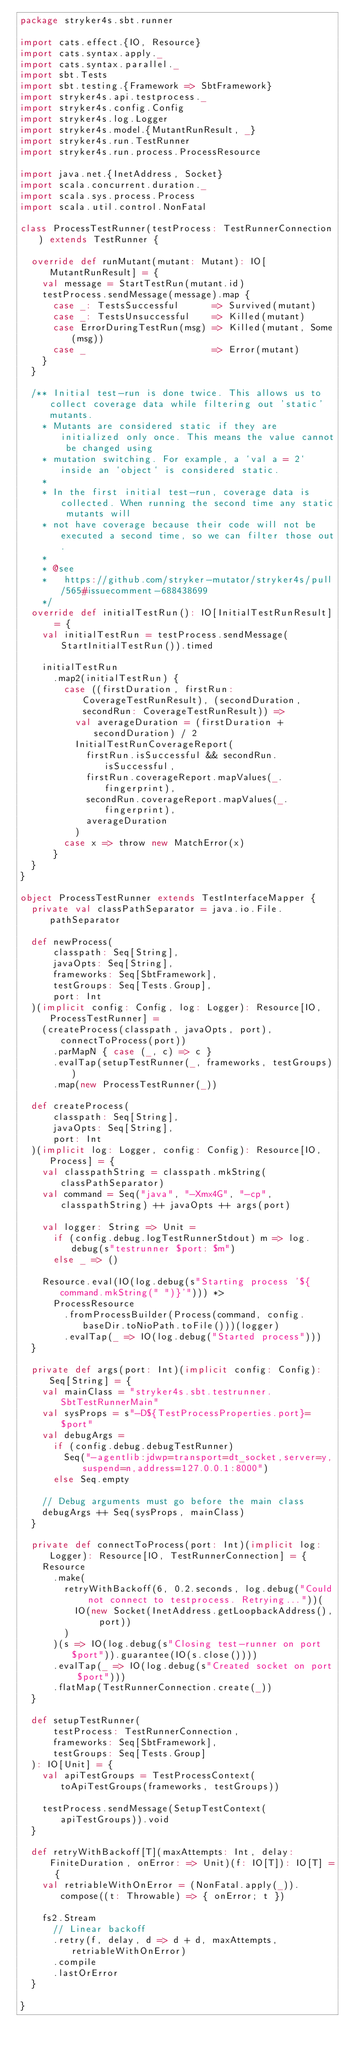Convert code to text. <code><loc_0><loc_0><loc_500><loc_500><_Scala_>package stryker4s.sbt.runner

import cats.effect.{IO, Resource}
import cats.syntax.apply._
import cats.syntax.parallel._
import sbt.Tests
import sbt.testing.{Framework => SbtFramework}
import stryker4s.api.testprocess._
import stryker4s.config.Config
import stryker4s.log.Logger
import stryker4s.model.{MutantRunResult, _}
import stryker4s.run.TestRunner
import stryker4s.run.process.ProcessResource

import java.net.{InetAddress, Socket}
import scala.concurrent.duration._
import scala.sys.process.Process
import scala.util.control.NonFatal

class ProcessTestRunner(testProcess: TestRunnerConnection) extends TestRunner {

  override def runMutant(mutant: Mutant): IO[MutantRunResult] = {
    val message = StartTestRun(mutant.id)
    testProcess.sendMessage(message).map {
      case _: TestsSuccessful      => Survived(mutant)
      case _: TestsUnsuccessful    => Killed(mutant)
      case ErrorDuringTestRun(msg) => Killed(mutant, Some(msg))
      case _                       => Error(mutant)
    }
  }

  /** Initial test-run is done twice. This allows us to collect coverage data while filtering out 'static' mutants.
    * Mutants are considered static if they are initialized only once. This means the value cannot be changed using
    * mutation switching. For example, a `val a = 2` inside an `object` is considered static.
    *
    * In the first initial test-run, coverage data is collected. When running the second time any static mutants will
    * not have coverage because their code will not be executed a second time, so we can filter those out.
    *
    * @see
    *   https://github.com/stryker-mutator/stryker4s/pull/565#issuecomment-688438699
    */
  override def initialTestRun(): IO[InitialTestRunResult] = {
    val initialTestRun = testProcess.sendMessage(StartInitialTestRun()).timed

    initialTestRun
      .map2(initialTestRun) {
        case ((firstDuration, firstRun: CoverageTestRunResult), (secondDuration, secondRun: CoverageTestRunResult)) =>
          val averageDuration = (firstDuration + secondDuration) / 2
          InitialTestRunCoverageReport(
            firstRun.isSuccessful && secondRun.isSuccessful,
            firstRun.coverageReport.mapValues(_.fingerprint),
            secondRun.coverageReport.mapValues(_.fingerprint),
            averageDuration
          )
        case x => throw new MatchError(x)
      }
  }
}

object ProcessTestRunner extends TestInterfaceMapper {
  private val classPathSeparator = java.io.File.pathSeparator

  def newProcess(
      classpath: Seq[String],
      javaOpts: Seq[String],
      frameworks: Seq[SbtFramework],
      testGroups: Seq[Tests.Group],
      port: Int
  )(implicit config: Config, log: Logger): Resource[IO, ProcessTestRunner] =
    (createProcess(classpath, javaOpts, port), connectToProcess(port))
      .parMapN { case (_, c) => c }
      .evalTap(setupTestRunner(_, frameworks, testGroups))
      .map(new ProcessTestRunner(_))

  def createProcess(
      classpath: Seq[String],
      javaOpts: Seq[String],
      port: Int
  )(implicit log: Logger, config: Config): Resource[IO, Process] = {
    val classpathString = classpath.mkString(classPathSeparator)
    val command = Seq("java", "-Xmx4G", "-cp", classpathString) ++ javaOpts ++ args(port)

    val logger: String => Unit =
      if (config.debug.logTestRunnerStdout) m => log.debug(s"testrunner $port: $m")
      else _ => ()

    Resource.eval(IO(log.debug(s"Starting process '${command.mkString(" ")}'"))) *>
      ProcessResource
        .fromProcessBuilder(Process(command, config.baseDir.toNioPath.toFile()))(logger)
        .evalTap(_ => IO(log.debug("Started process")))
  }

  private def args(port: Int)(implicit config: Config): Seq[String] = {
    val mainClass = "stryker4s.sbt.testrunner.SbtTestRunnerMain"
    val sysProps = s"-D${TestProcessProperties.port}=$port"
    val debugArgs =
      if (config.debug.debugTestRunner)
        Seq("-agentlib:jdwp=transport=dt_socket,server=y,suspend=n,address=127.0.0.1:8000")
      else Seq.empty

    // Debug arguments must go before the main class
    debugArgs ++ Seq(sysProps, mainClass)
  }

  private def connectToProcess(port: Int)(implicit log: Logger): Resource[IO, TestRunnerConnection] = {
    Resource
      .make(
        retryWithBackoff(6, 0.2.seconds, log.debug("Could not connect to testprocess. Retrying..."))(
          IO(new Socket(InetAddress.getLoopbackAddress(), port))
        )
      )(s => IO(log.debug(s"Closing test-runner on port $port")).guarantee(IO(s.close())))
      .evalTap(_ => IO(log.debug(s"Created socket on port $port")))
      .flatMap(TestRunnerConnection.create(_))
  }

  def setupTestRunner(
      testProcess: TestRunnerConnection,
      frameworks: Seq[SbtFramework],
      testGroups: Seq[Tests.Group]
  ): IO[Unit] = {
    val apiTestGroups = TestProcessContext(toApiTestGroups(frameworks, testGroups))

    testProcess.sendMessage(SetupTestContext(apiTestGroups)).void
  }

  def retryWithBackoff[T](maxAttempts: Int, delay: FiniteDuration, onError: => Unit)(f: IO[T]): IO[T] = {
    val retriableWithOnError = (NonFatal.apply(_)).compose((t: Throwable) => { onError; t })

    fs2.Stream
      // Linear backoff
      .retry(f, delay, d => d + d, maxAttempts, retriableWithOnError)
      .compile
      .lastOrError
  }

}
</code> 